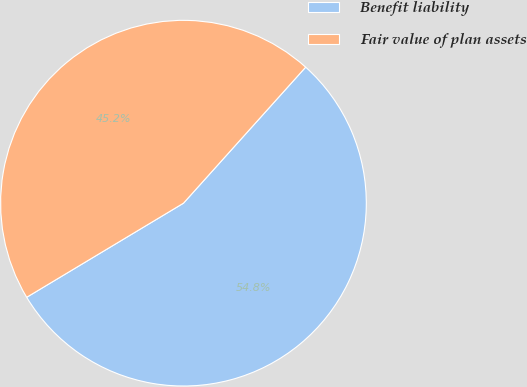Convert chart. <chart><loc_0><loc_0><loc_500><loc_500><pie_chart><fcel>Benefit liability<fcel>Fair value of plan assets<nl><fcel>54.75%<fcel>45.25%<nl></chart> 